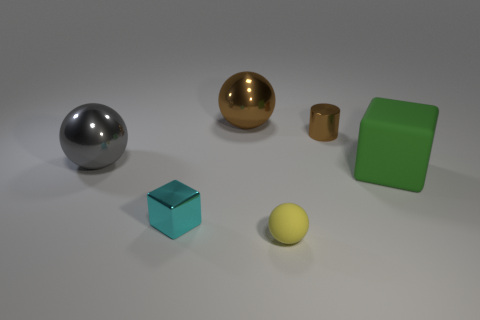Subtract all small yellow rubber balls. How many balls are left? 2 Add 2 large yellow shiny spheres. How many objects exist? 8 Subtract all cylinders. How many objects are left? 5 Add 1 big gray matte things. How many big gray matte things exist? 1 Subtract 0 cyan cylinders. How many objects are left? 6 Subtract all rubber cubes. Subtract all gray metal spheres. How many objects are left? 4 Add 6 large brown objects. How many large brown objects are left? 7 